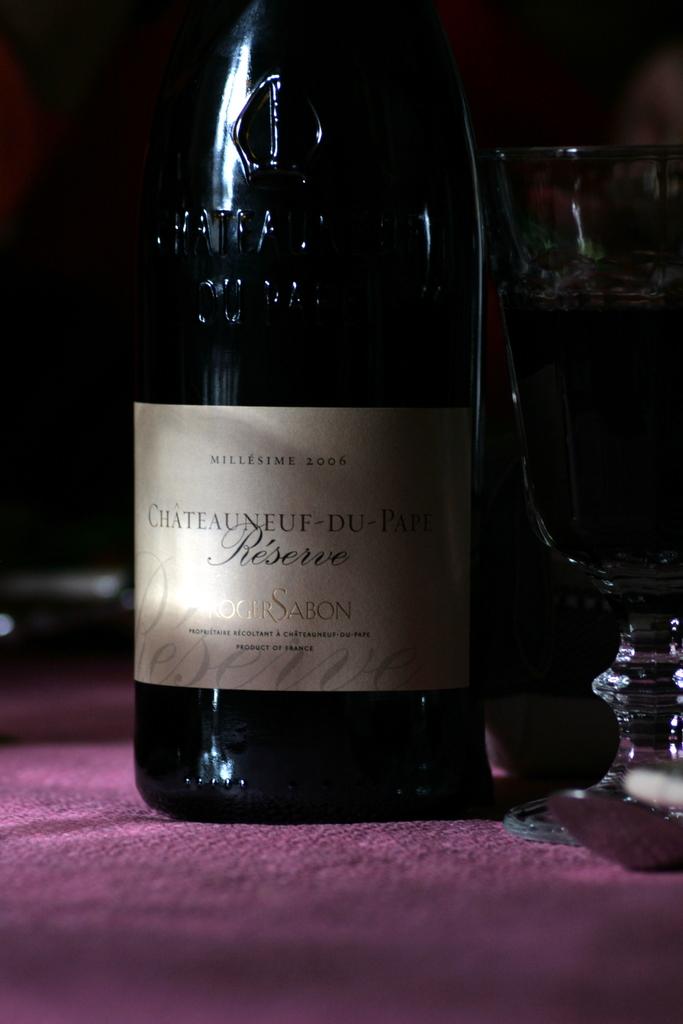What kind of wine is this?
Your answer should be very brief. Sabon. What year is the wine?
Keep it short and to the point. 2006. 